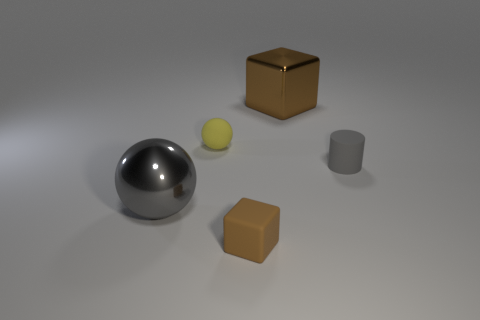How many tiny things are matte blocks or yellow spheres?
Offer a very short reply. 2. Are the brown object that is in front of the large shiny sphere and the tiny ball made of the same material?
Your answer should be compact. Yes. There is a brown object that is on the right side of the brown thing that is left of the big object that is on the right side of the big gray object; what is its shape?
Provide a short and direct response. Cube. How many brown things are either metal objects or metallic blocks?
Provide a succinct answer. 1. Are there an equal number of large objects right of the gray rubber cylinder and shiny blocks to the right of the small rubber ball?
Keep it short and to the point. No. There is a gray object that is on the right side of the gray metallic ball; is it the same shape as the large shiny object left of the brown matte thing?
Provide a short and direct response. No. Is there anything else that is the same shape as the yellow rubber thing?
Your answer should be compact. Yes. There is a small gray object that is the same material as the small yellow sphere; what is its shape?
Provide a succinct answer. Cylinder. Is the number of metallic blocks on the right side of the cylinder the same as the number of small yellow objects?
Your response must be concise. No. Are the brown thing that is in front of the large brown metal object and the tiny object that is to the right of the big brown metal block made of the same material?
Your response must be concise. Yes. 